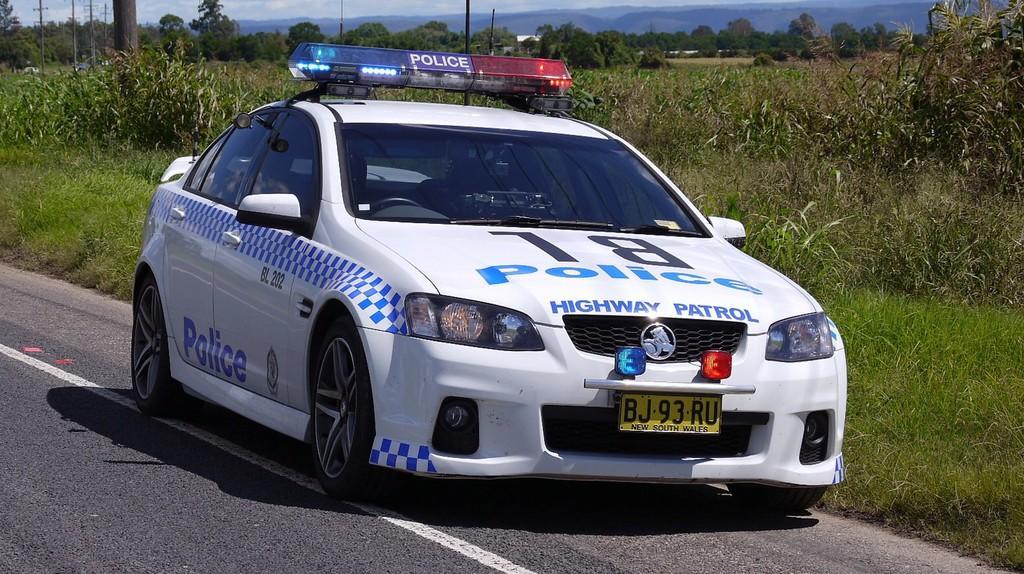In one or two sentences, can you explain what this image depicts? In this image in the center there is one car, at the bottom there is road, grass and in the background there are some trees, poles, mountains and some plants. 